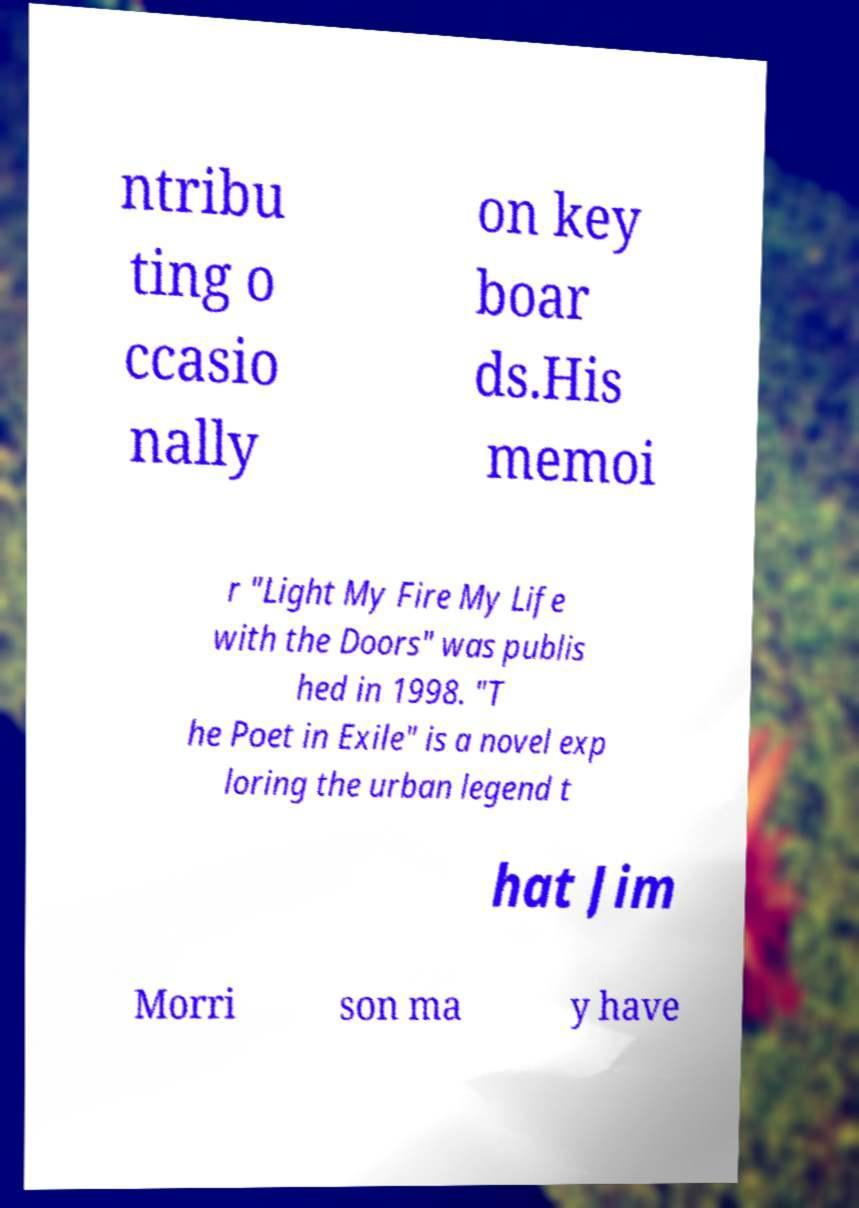Could you extract and type out the text from this image? ntribu ting o ccasio nally on key boar ds.His memoi r "Light My Fire My Life with the Doors" was publis hed in 1998. "T he Poet in Exile" is a novel exp loring the urban legend t hat Jim Morri son ma y have 